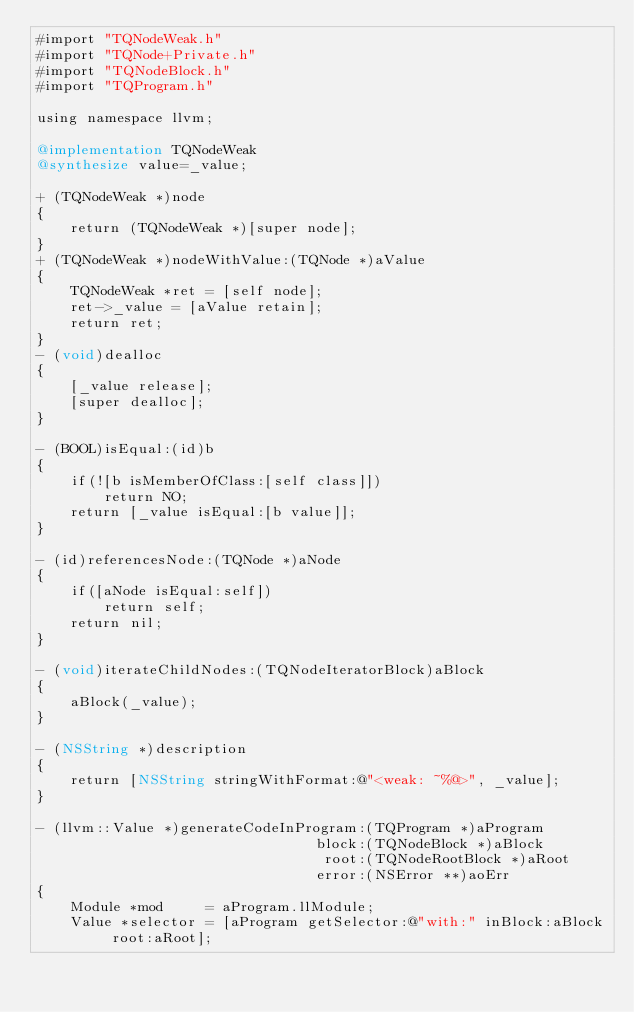Convert code to text. <code><loc_0><loc_0><loc_500><loc_500><_ObjectiveC_>#import "TQNodeWeak.h"
#import "TQNode+Private.h"
#import "TQNodeBlock.h"
#import "TQProgram.h"

using namespace llvm;

@implementation TQNodeWeak
@synthesize value=_value;

+ (TQNodeWeak *)node
{
    return (TQNodeWeak *)[super node];
}
+ (TQNodeWeak *)nodeWithValue:(TQNode *)aValue
{
    TQNodeWeak *ret = [self node];
    ret->_value = [aValue retain];
    return ret;
}
- (void)dealloc
{
    [_value release];
    [super dealloc];
}

- (BOOL)isEqual:(id)b
{
    if(![b isMemberOfClass:[self class]])
        return NO;
    return [_value isEqual:[b value]];
}

- (id)referencesNode:(TQNode *)aNode
{
    if([aNode isEqual:self])
        return self;
    return nil;
}

- (void)iterateChildNodes:(TQNodeIteratorBlock)aBlock
{
    aBlock(_value);
}

- (NSString *)description
{
    return [NSString stringWithFormat:@"<weak: ~%@>", _value];
}

- (llvm::Value *)generateCodeInProgram:(TQProgram *)aProgram
                                 block:(TQNodeBlock *)aBlock
                                  root:(TQNodeRootBlock *)aRoot
                                 error:(NSError **)aoErr
{
    Module *mod     = aProgram.llModule;
    Value *selector = [aProgram getSelector:@"with:" inBlock:aBlock root:aRoot];</code> 